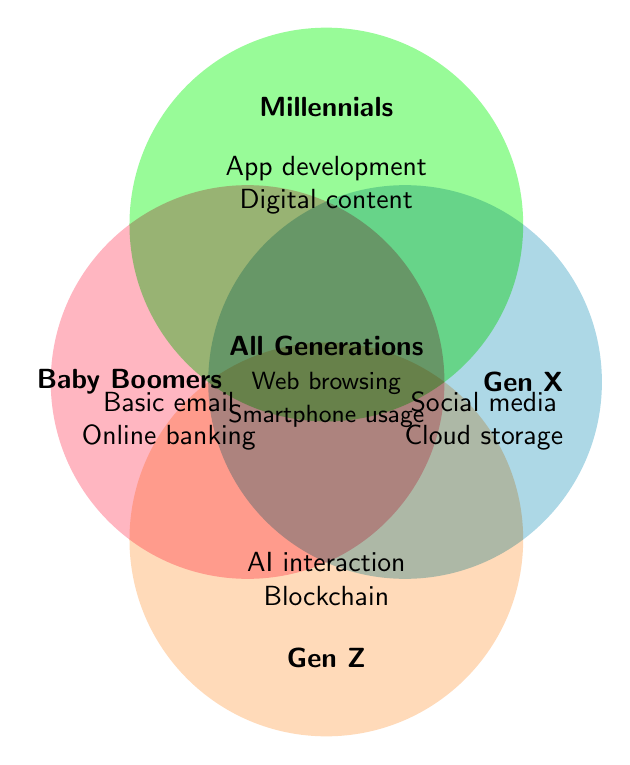How many generations have basic email literacy? To answer this, observe each labeled section in the Venn Diagram. Notice that **Basic email** is listed under **Baby Boomers**. Identify which generation Baby Boomers represent.
Answer: One Which digital literacy skills are shared by all generations? In the Venn Diagram, the center overlapping section indicates the skills shared by all generations. The skills listed here are **Web browsing** and **Smartphone usage**.
Answer: Web browsing, Smartphone usage Which generation is associated with AI interaction skills? Look for the digital literacy skills under the section labeled **Gen Z**. The mentioned skills are **AI interaction** and **Blockchain understanding**.
Answer: Gen Z What digital literacy skills are unique to Millennials? Identify the skills listed under **Millennials** without any overlap into other sections. The skills under **Millennials** are **App development** and **Digital content creation**.
Answer: App development, Digital content creation How many unique digital literacy skills are identified in the whole diagram? Count each distinct skill mentioned in all the sections: Basic email, Online banking (Baby Boomers); Social media proficiency, Cloud storage use (Gen X); App development, Digital content creation (Millennials); AI interaction, Blockchain understanding (Gen Z); Web browsing, Smartphone usage (All Generations).
Answer: 10 Do Baby Boomers and Gen X share any skills? Examine the intersections between Baby Boomers and Gen X sections in the Venn Diagram. No skills appear in the overlapping region between these two generations.
Answer: No Compare the number of skills mentioned for Millennials versus Gen Z. Count the skills for each: Millennials have **App development** and **Digital content creation** (2 skills); Gen Z has **AI interaction** and **Blockchain understanding** (2 skills).
Answer: The same (2 skills each) Which group has proficiency in cloud storage use? Refer to the skills listed under **Gen X** in the figure. **Cloud storage use** is mentioned under the Gen X label.
Answer: Gen X 